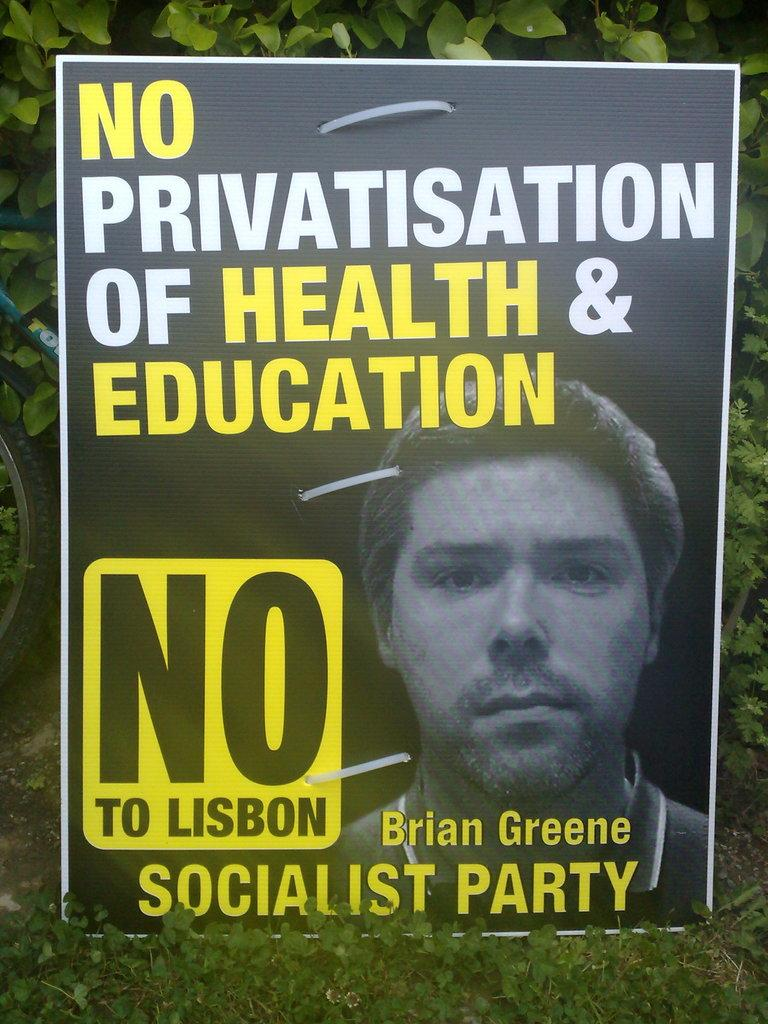What type of visual is the image in the picture? The image is a poster. What is depicted on the poster? There is an image of a person on the poster. Are there any other elements on the poster besides the person? Yes, there are leaves of a plant on the poster. What type of cough medicine is recommended by the doctor on the poster? There is no doctor or cough medicine mentioned on the poster; it features an image of a person and leaves of a plant. 